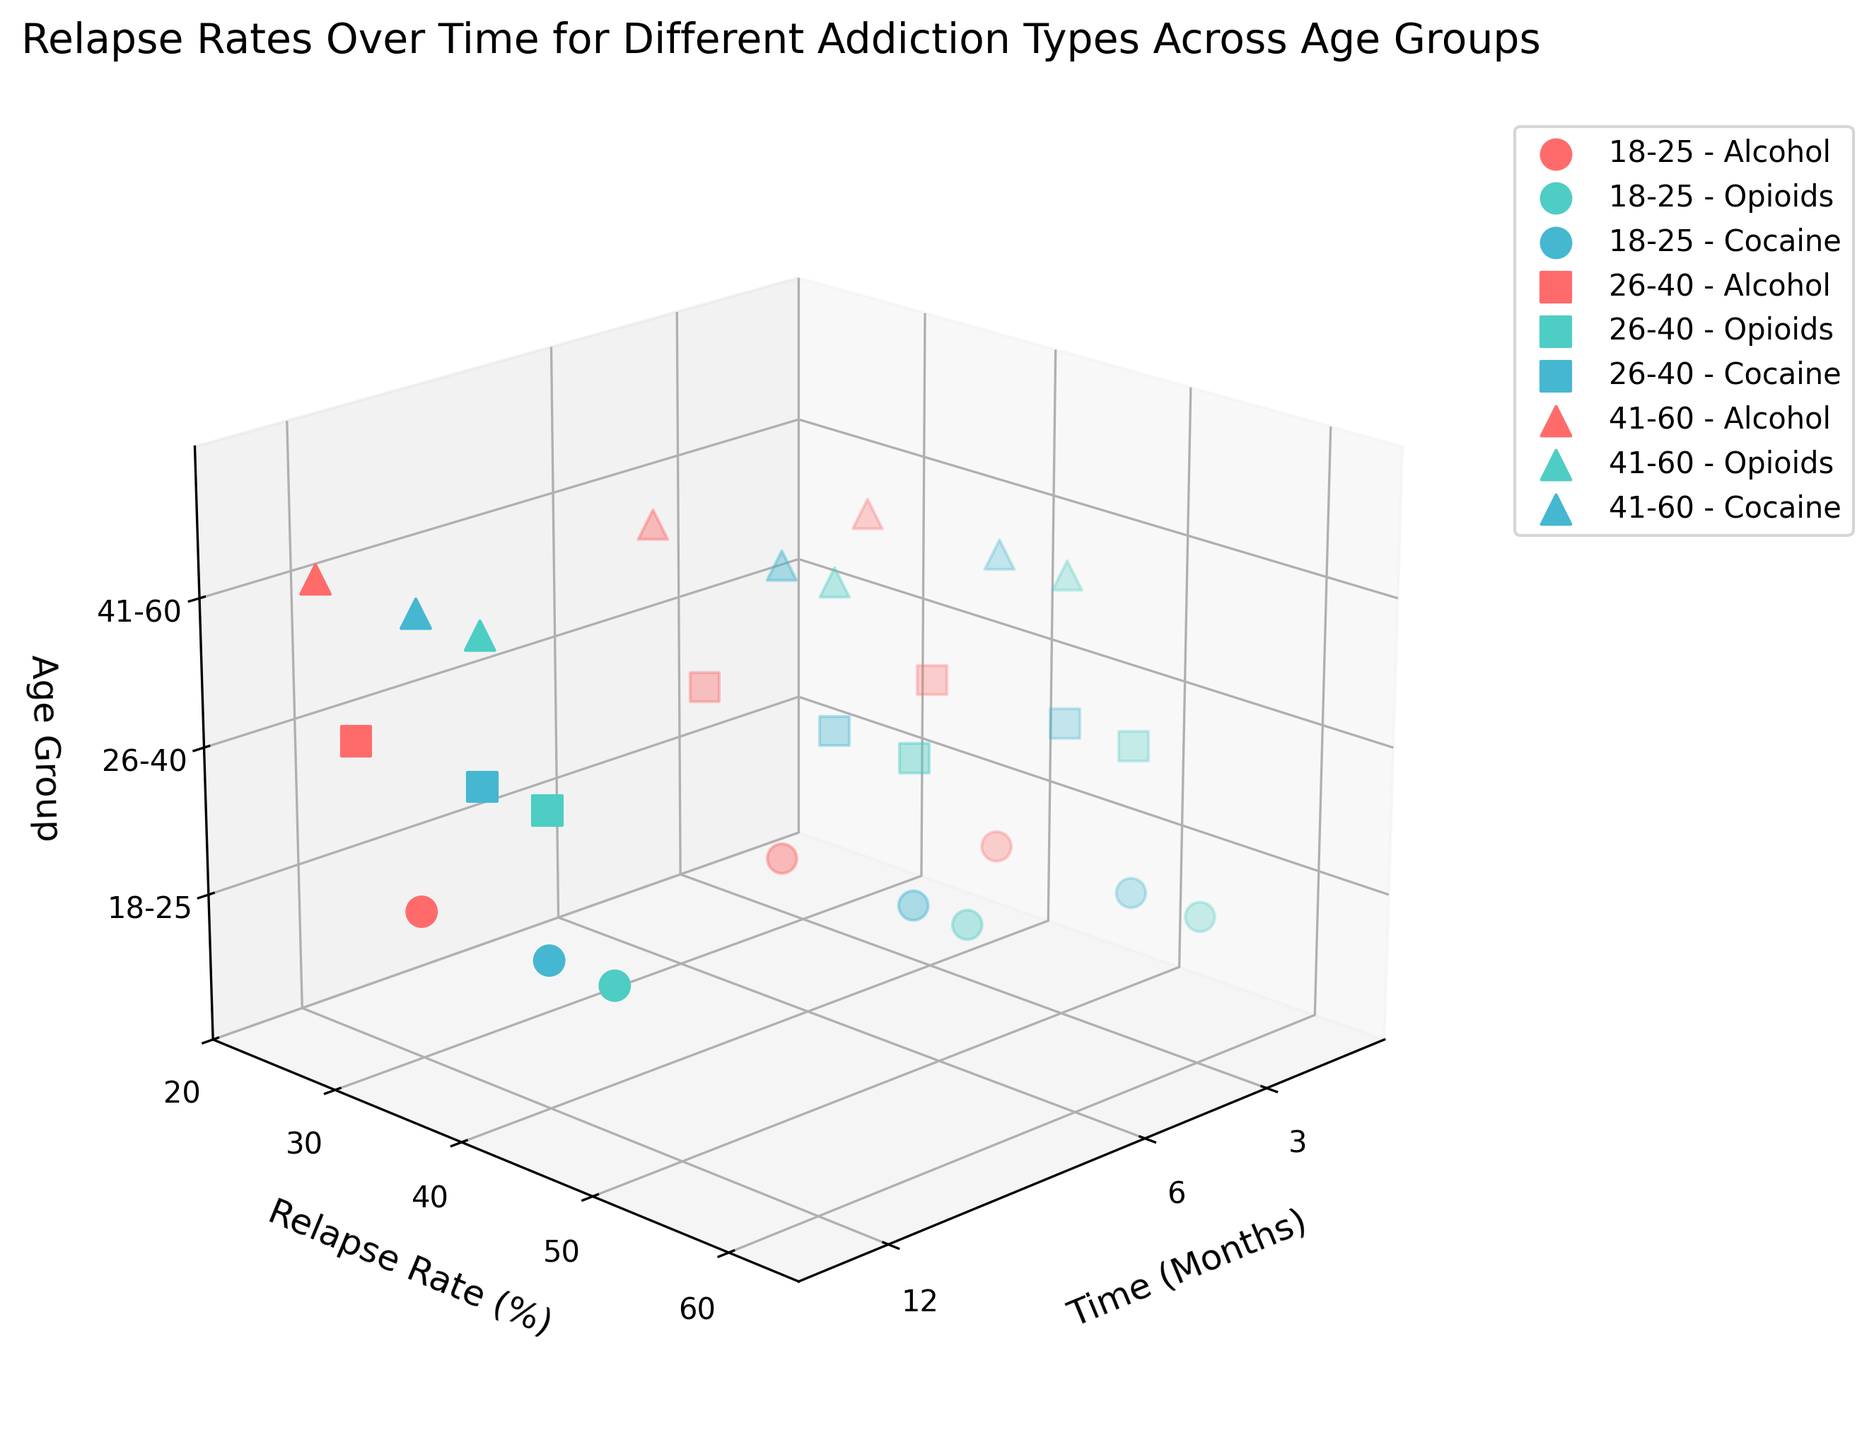what are the age groups considered in the plot? The plot legend distinguishes between various age groups represented in the Z-axis labels and different markers in the plot. These age groups are mentioned distinctly as 18-25, 26-40, and 41-60.
Answer: 18-25, 26-40, 41-60 Which addiction type consistently shows the highest relapse rate at 3 months across all age groups? By examining the 3D scatter plot, observe the points corresponding to 3 months on the X-axis. Compare the Y-axis values (Relapse Rate) for Alcohol, Opioids, and Cocaine across the age groups. Opioids have the highest relapse rates at 3 months across all age groups.
Answer: Opioids What is the lowest relapse rate observed for the 18-25 age group? Look at the Z-axis marking for the 18-25 age group. Examine the relapse rate percentages (Y-axis) across different times (X-axis) and addiction types. The lowest relapse rate for this group is for Alcohol at 12 months, which is 30%.
Answer: 30% How does the relapse rate for Alcohol change from 3 to 12 months for the 26-40 age group? Locate the scatter points on the plot for Alcohol (identified by the legend and colors) within the 26-40 age group. Analyze the change in relapse rate percentages from 3 months to 12 months. The relapse rate for Alcohol in the 26-40 age group drops from 40% at 3 months to 25% at 12 months.
Answer: Decreases from 40% to 25% Between the age groups 26-40 and 41-60, which has a lower relapse rate for Cocaine at 6 months? Identify the scatter points on the plot for Cocaine (identified by the legend and colors) at 6 months for both 26-40 and 41-60 age groups. By comparing the Y-axis values, the 41-60 age group has a relapse rate of 38%, while the 26-40 age group has 42%.
Answer: 41-60 What trend do you notice in the relapse rate for the opioids addiction type within the 41-60 age group over 12 months? Focus on the 41-60 age group's points related to Opioids (identified by the legend). The Y-axis values for the 3 months, 6 months, and 12 months points indicate a decreasing trend. From 50% at 3 months to 35% at 12 months, it steadily decreases.
Answer: Decreasing trend Which age group shows the most significant decrease in relapse rate for Cocaine from 3 months to 12 months? Compare the differences in relapse rates (Y-axis) for the three age groups from 3 months to 12 months for Cocaine (identified by legend and colors). The 18-25 age group shows a decrease from 55% to 40%, a difference of 15%, which is the most significant drop.
Answer: 18-25 Are there any addiction types that do not follow a decreasing relapse rate trend over time within the same age group? Upon examining all the scatter points for each addiction type within the same age groups, all addiction types display a decreasing trend in relapse rates over time. Thus, none of the addiction types deviate from this pattern.
Answer: No Which addiction type generally has the highest relapse rate at 6 months for age groups 41-60? Identify all scatter points at 6 months (X-axis) for the 41-60 age group (Z-axis for 41-60). Compare the relapse rates (Y-axis) for Alcohol, Opioids, and Cocaine at that point. Opioids at 6 months have the highest relapse rate of 42%.
Answer: Opioids 